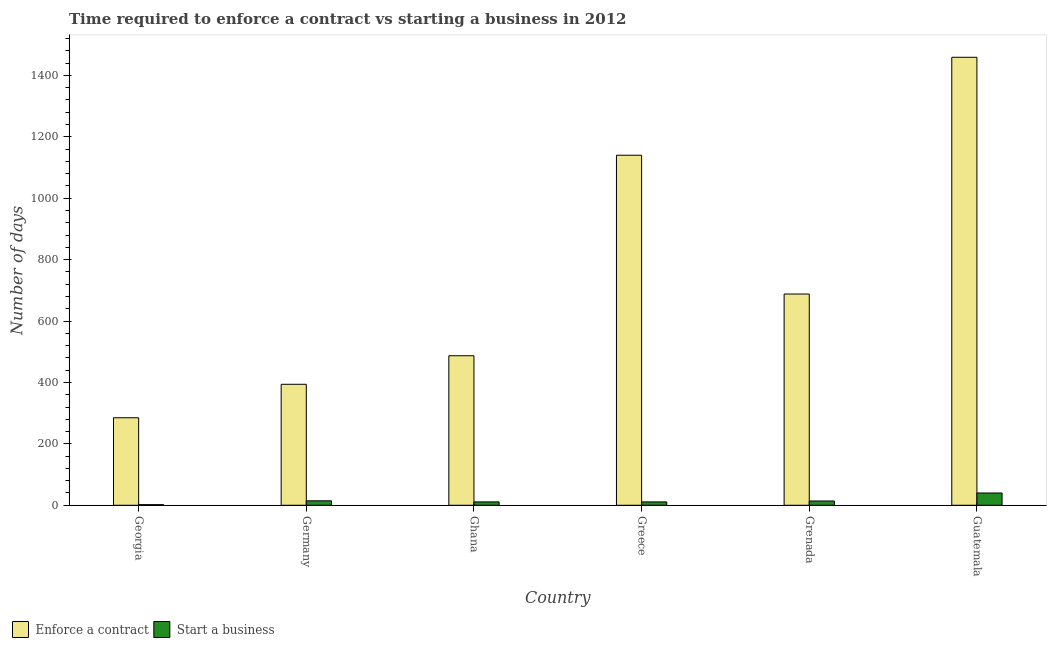How many different coloured bars are there?
Your answer should be compact. 2. Are the number of bars per tick equal to the number of legend labels?
Your response must be concise. Yes. How many bars are there on the 1st tick from the left?
Your answer should be compact. 2. How many bars are there on the 5th tick from the right?
Provide a succinct answer. 2. What is the label of the 2nd group of bars from the left?
Make the answer very short. Germany. What is the number of days to start a business in Greece?
Ensure brevity in your answer.  11. Across all countries, what is the minimum number of days to enforece a contract?
Offer a very short reply. 285. In which country was the number of days to start a business maximum?
Make the answer very short. Guatemala. In which country was the number of days to start a business minimum?
Keep it short and to the point. Georgia. What is the total number of days to start a business in the graph?
Make the answer very short. 92.5. What is the difference between the number of days to start a business in Georgia and that in Guatemala?
Provide a short and direct response. -38. What is the difference between the number of days to start a business in Ghana and the number of days to enforece a contract in Grenada?
Give a very brief answer. -677. What is the average number of days to start a business per country?
Your response must be concise. 15.42. What is the difference between the number of days to start a business and number of days to enforece a contract in Georgia?
Make the answer very short. -283. What is the ratio of the number of days to start a business in Greece to that in Guatemala?
Offer a very short reply. 0.28. Is the number of days to start a business in Ghana less than that in Guatemala?
Offer a terse response. Yes. Is the difference between the number of days to enforece a contract in Greece and Grenada greater than the difference between the number of days to start a business in Greece and Grenada?
Provide a succinct answer. Yes. What is the difference between the highest and the second highest number of days to enforece a contract?
Offer a very short reply. 319. What is the difference between the highest and the lowest number of days to start a business?
Make the answer very short. 38. In how many countries, is the number of days to start a business greater than the average number of days to start a business taken over all countries?
Your answer should be compact. 1. Is the sum of the number of days to start a business in Grenada and Guatemala greater than the maximum number of days to enforece a contract across all countries?
Provide a succinct answer. No. What does the 2nd bar from the left in Ghana represents?
Keep it short and to the point. Start a business. What does the 2nd bar from the right in Georgia represents?
Your answer should be compact. Enforce a contract. How many bars are there?
Your answer should be very brief. 12. What is the difference between two consecutive major ticks on the Y-axis?
Offer a terse response. 200. Does the graph contain grids?
Offer a very short reply. No. How are the legend labels stacked?
Ensure brevity in your answer.  Horizontal. What is the title of the graph?
Provide a short and direct response. Time required to enforce a contract vs starting a business in 2012. Does "Rural Population" appear as one of the legend labels in the graph?
Offer a very short reply. No. What is the label or title of the Y-axis?
Ensure brevity in your answer.  Number of days. What is the Number of days of Enforce a contract in Georgia?
Give a very brief answer. 285. What is the Number of days of Enforce a contract in Germany?
Your response must be concise. 394. What is the Number of days in Start a business in Germany?
Provide a succinct answer. 14.5. What is the Number of days of Enforce a contract in Ghana?
Provide a succinct answer. 487. What is the Number of days in Enforce a contract in Greece?
Offer a very short reply. 1140. What is the Number of days of Start a business in Greece?
Provide a succinct answer. 11. What is the Number of days in Enforce a contract in Grenada?
Provide a succinct answer. 688. What is the Number of days in Enforce a contract in Guatemala?
Provide a succinct answer. 1459. Across all countries, what is the maximum Number of days in Enforce a contract?
Provide a short and direct response. 1459. Across all countries, what is the minimum Number of days in Enforce a contract?
Make the answer very short. 285. Across all countries, what is the minimum Number of days in Start a business?
Offer a terse response. 2. What is the total Number of days of Enforce a contract in the graph?
Keep it short and to the point. 4453. What is the total Number of days in Start a business in the graph?
Provide a short and direct response. 92.5. What is the difference between the Number of days in Enforce a contract in Georgia and that in Germany?
Give a very brief answer. -109. What is the difference between the Number of days of Start a business in Georgia and that in Germany?
Give a very brief answer. -12.5. What is the difference between the Number of days of Enforce a contract in Georgia and that in Ghana?
Make the answer very short. -202. What is the difference between the Number of days in Enforce a contract in Georgia and that in Greece?
Provide a short and direct response. -855. What is the difference between the Number of days of Enforce a contract in Georgia and that in Grenada?
Keep it short and to the point. -403. What is the difference between the Number of days in Enforce a contract in Georgia and that in Guatemala?
Make the answer very short. -1174. What is the difference between the Number of days in Start a business in Georgia and that in Guatemala?
Offer a very short reply. -38. What is the difference between the Number of days in Enforce a contract in Germany and that in Ghana?
Your answer should be very brief. -93. What is the difference between the Number of days in Enforce a contract in Germany and that in Greece?
Provide a succinct answer. -746. What is the difference between the Number of days in Start a business in Germany and that in Greece?
Your answer should be compact. 3.5. What is the difference between the Number of days of Enforce a contract in Germany and that in Grenada?
Give a very brief answer. -294. What is the difference between the Number of days in Start a business in Germany and that in Grenada?
Offer a terse response. 0.5. What is the difference between the Number of days of Enforce a contract in Germany and that in Guatemala?
Your answer should be compact. -1065. What is the difference between the Number of days in Start a business in Germany and that in Guatemala?
Your answer should be compact. -25.5. What is the difference between the Number of days in Enforce a contract in Ghana and that in Greece?
Give a very brief answer. -653. What is the difference between the Number of days of Enforce a contract in Ghana and that in Grenada?
Provide a short and direct response. -201. What is the difference between the Number of days of Start a business in Ghana and that in Grenada?
Offer a very short reply. -3. What is the difference between the Number of days in Enforce a contract in Ghana and that in Guatemala?
Make the answer very short. -972. What is the difference between the Number of days in Start a business in Ghana and that in Guatemala?
Offer a terse response. -29. What is the difference between the Number of days in Enforce a contract in Greece and that in Grenada?
Provide a succinct answer. 452. What is the difference between the Number of days in Start a business in Greece and that in Grenada?
Your answer should be very brief. -3. What is the difference between the Number of days of Enforce a contract in Greece and that in Guatemala?
Keep it short and to the point. -319. What is the difference between the Number of days of Enforce a contract in Grenada and that in Guatemala?
Your answer should be compact. -771. What is the difference between the Number of days of Start a business in Grenada and that in Guatemala?
Keep it short and to the point. -26. What is the difference between the Number of days in Enforce a contract in Georgia and the Number of days in Start a business in Germany?
Make the answer very short. 270.5. What is the difference between the Number of days in Enforce a contract in Georgia and the Number of days in Start a business in Ghana?
Your response must be concise. 274. What is the difference between the Number of days of Enforce a contract in Georgia and the Number of days of Start a business in Greece?
Offer a very short reply. 274. What is the difference between the Number of days of Enforce a contract in Georgia and the Number of days of Start a business in Grenada?
Your answer should be very brief. 271. What is the difference between the Number of days of Enforce a contract in Georgia and the Number of days of Start a business in Guatemala?
Ensure brevity in your answer.  245. What is the difference between the Number of days of Enforce a contract in Germany and the Number of days of Start a business in Ghana?
Offer a terse response. 383. What is the difference between the Number of days of Enforce a contract in Germany and the Number of days of Start a business in Greece?
Ensure brevity in your answer.  383. What is the difference between the Number of days in Enforce a contract in Germany and the Number of days in Start a business in Grenada?
Make the answer very short. 380. What is the difference between the Number of days in Enforce a contract in Germany and the Number of days in Start a business in Guatemala?
Offer a very short reply. 354. What is the difference between the Number of days in Enforce a contract in Ghana and the Number of days in Start a business in Greece?
Give a very brief answer. 476. What is the difference between the Number of days in Enforce a contract in Ghana and the Number of days in Start a business in Grenada?
Make the answer very short. 473. What is the difference between the Number of days in Enforce a contract in Ghana and the Number of days in Start a business in Guatemala?
Provide a short and direct response. 447. What is the difference between the Number of days in Enforce a contract in Greece and the Number of days in Start a business in Grenada?
Provide a succinct answer. 1126. What is the difference between the Number of days in Enforce a contract in Greece and the Number of days in Start a business in Guatemala?
Offer a very short reply. 1100. What is the difference between the Number of days in Enforce a contract in Grenada and the Number of days in Start a business in Guatemala?
Your answer should be very brief. 648. What is the average Number of days in Enforce a contract per country?
Your answer should be very brief. 742.17. What is the average Number of days in Start a business per country?
Offer a terse response. 15.42. What is the difference between the Number of days in Enforce a contract and Number of days in Start a business in Georgia?
Offer a very short reply. 283. What is the difference between the Number of days of Enforce a contract and Number of days of Start a business in Germany?
Keep it short and to the point. 379.5. What is the difference between the Number of days in Enforce a contract and Number of days in Start a business in Ghana?
Give a very brief answer. 476. What is the difference between the Number of days of Enforce a contract and Number of days of Start a business in Greece?
Ensure brevity in your answer.  1129. What is the difference between the Number of days in Enforce a contract and Number of days in Start a business in Grenada?
Provide a succinct answer. 674. What is the difference between the Number of days of Enforce a contract and Number of days of Start a business in Guatemala?
Your response must be concise. 1419. What is the ratio of the Number of days in Enforce a contract in Georgia to that in Germany?
Provide a short and direct response. 0.72. What is the ratio of the Number of days in Start a business in Georgia to that in Germany?
Your answer should be very brief. 0.14. What is the ratio of the Number of days of Enforce a contract in Georgia to that in Ghana?
Offer a terse response. 0.59. What is the ratio of the Number of days in Start a business in Georgia to that in Ghana?
Your answer should be very brief. 0.18. What is the ratio of the Number of days in Enforce a contract in Georgia to that in Greece?
Your answer should be very brief. 0.25. What is the ratio of the Number of days in Start a business in Georgia to that in Greece?
Make the answer very short. 0.18. What is the ratio of the Number of days in Enforce a contract in Georgia to that in Grenada?
Make the answer very short. 0.41. What is the ratio of the Number of days in Start a business in Georgia to that in Grenada?
Keep it short and to the point. 0.14. What is the ratio of the Number of days of Enforce a contract in Georgia to that in Guatemala?
Ensure brevity in your answer.  0.2. What is the ratio of the Number of days of Start a business in Georgia to that in Guatemala?
Offer a terse response. 0.05. What is the ratio of the Number of days of Enforce a contract in Germany to that in Ghana?
Your answer should be very brief. 0.81. What is the ratio of the Number of days in Start a business in Germany to that in Ghana?
Offer a very short reply. 1.32. What is the ratio of the Number of days of Enforce a contract in Germany to that in Greece?
Your answer should be compact. 0.35. What is the ratio of the Number of days of Start a business in Germany to that in Greece?
Your answer should be compact. 1.32. What is the ratio of the Number of days in Enforce a contract in Germany to that in Grenada?
Provide a short and direct response. 0.57. What is the ratio of the Number of days of Start a business in Germany to that in Grenada?
Offer a very short reply. 1.04. What is the ratio of the Number of days of Enforce a contract in Germany to that in Guatemala?
Offer a very short reply. 0.27. What is the ratio of the Number of days of Start a business in Germany to that in Guatemala?
Offer a very short reply. 0.36. What is the ratio of the Number of days of Enforce a contract in Ghana to that in Greece?
Your response must be concise. 0.43. What is the ratio of the Number of days in Start a business in Ghana to that in Greece?
Offer a terse response. 1. What is the ratio of the Number of days in Enforce a contract in Ghana to that in Grenada?
Provide a succinct answer. 0.71. What is the ratio of the Number of days of Start a business in Ghana to that in Grenada?
Your answer should be very brief. 0.79. What is the ratio of the Number of days of Enforce a contract in Ghana to that in Guatemala?
Ensure brevity in your answer.  0.33. What is the ratio of the Number of days of Start a business in Ghana to that in Guatemala?
Offer a terse response. 0.28. What is the ratio of the Number of days in Enforce a contract in Greece to that in Grenada?
Your answer should be compact. 1.66. What is the ratio of the Number of days in Start a business in Greece to that in Grenada?
Provide a succinct answer. 0.79. What is the ratio of the Number of days in Enforce a contract in Greece to that in Guatemala?
Your answer should be very brief. 0.78. What is the ratio of the Number of days of Start a business in Greece to that in Guatemala?
Ensure brevity in your answer.  0.28. What is the ratio of the Number of days of Enforce a contract in Grenada to that in Guatemala?
Offer a terse response. 0.47. What is the difference between the highest and the second highest Number of days of Enforce a contract?
Keep it short and to the point. 319. What is the difference between the highest and the second highest Number of days in Start a business?
Provide a succinct answer. 25.5. What is the difference between the highest and the lowest Number of days in Enforce a contract?
Give a very brief answer. 1174. 